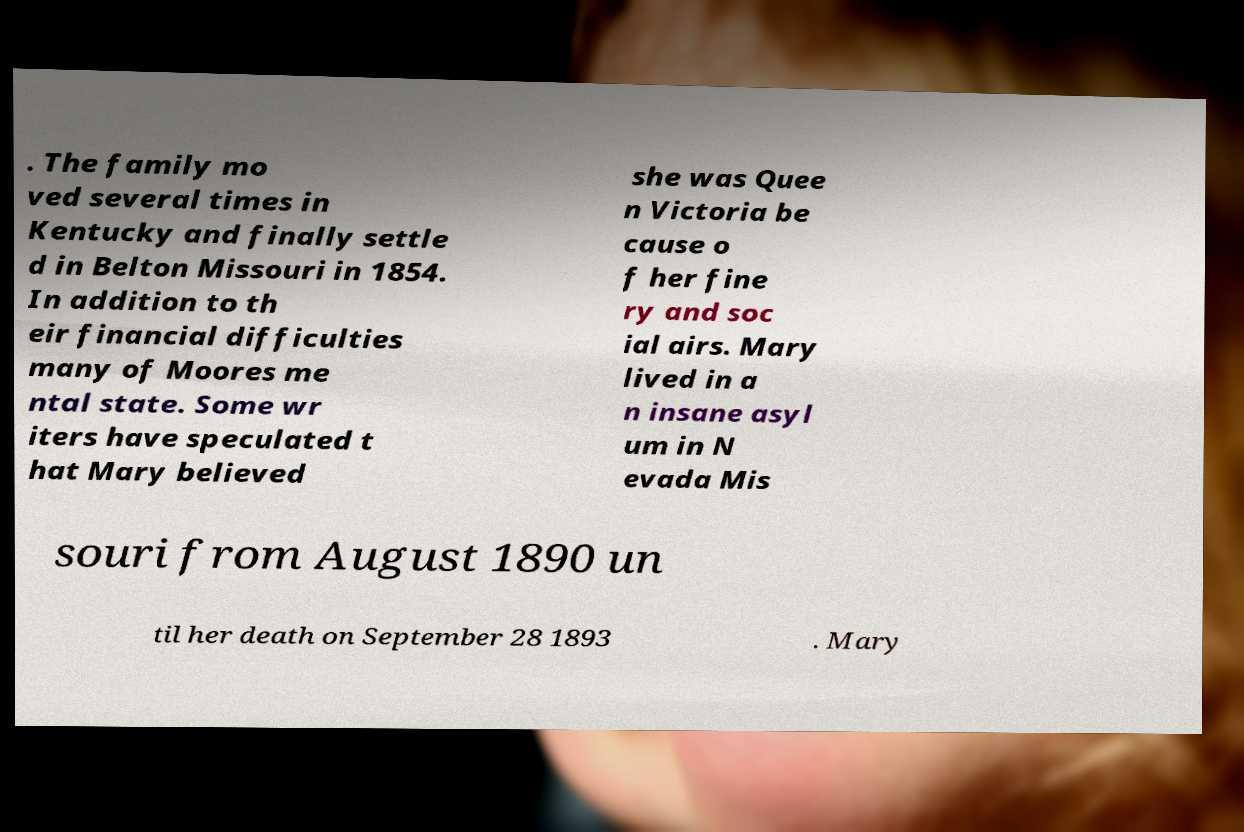Can you elaborate on the implications of the speculations surrounding Mary's mental state as mentioned in the image? The text notes that some writers speculated Mary believed she was Queen Victoria, highlighting a folklore-like intrigue about her mental state. This raises questions about the treatment and societal perceptions of mental health during that era, especially regarding individuals in public or high social standings. 